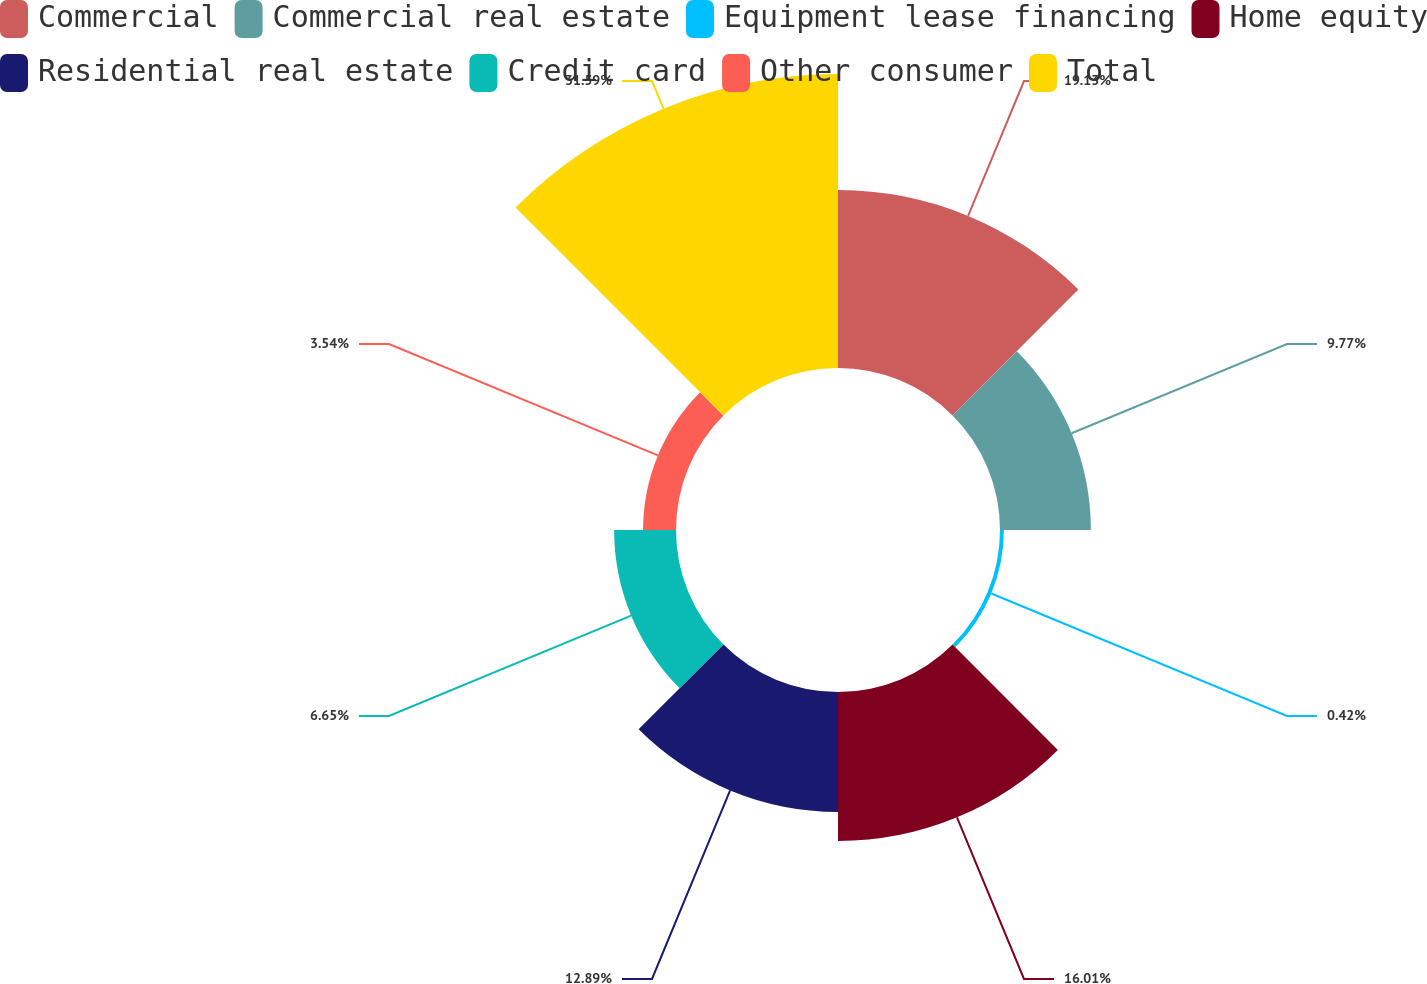Convert chart to OTSL. <chart><loc_0><loc_0><loc_500><loc_500><pie_chart><fcel>Commercial<fcel>Commercial real estate<fcel>Equipment lease financing<fcel>Home equity<fcel>Residential real estate<fcel>Credit card<fcel>Other consumer<fcel>Total<nl><fcel>19.13%<fcel>9.77%<fcel>0.42%<fcel>16.01%<fcel>12.89%<fcel>6.65%<fcel>3.54%<fcel>31.6%<nl></chart> 